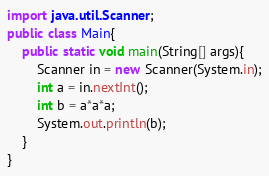<code> <loc_0><loc_0><loc_500><loc_500><_Java_>import java.util.Scanner;
public class Main{
	public static void main(String[] args){
		Scanner in = new Scanner(System.in);
		int a = in.nextInt();
		int b = a*a*a;
		System.out.println(b);
	}
}</code> 